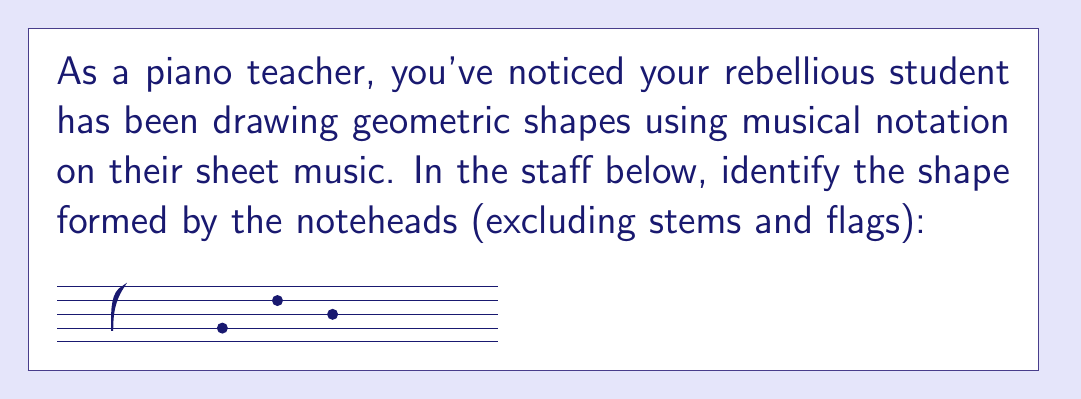Give your solution to this math problem. To identify the shape formed by the noteheads, we need to follow these steps:

1. Locate the noteheads on the staff:
   - First note: 3rd space from the bottom
   - Second note: 3rd line from the bottom
   - Third note: 2nd space from the bottom

2. Mentally connect these points:
   - If we draw lines between these three points, we form a shape with three vertices and three straight sides.

3. Analyze the properties of the shape:
   - The shape has three vertices (corner points)
   - It has three straight sides
   - The sides are not all equal in length
   - The angles are not all equal

4. Identify the geometric shape:
   Based on these properties, the shape formed by the noteheads is a triangle. Specifically, it appears to be a scalene triangle, as the sides are not equal in length.

In musical notation, this arrangement of notes could represent a triad chord, which is fitting given the triangular shape it forms.
Answer: Triangle 